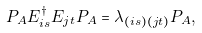<formula> <loc_0><loc_0><loc_500><loc_500>P _ { A } E _ { i s } ^ { \dagger } E _ { j t } P _ { A } = \lambda _ { ( i s ) ( j t ) } P _ { A } ,</formula> 